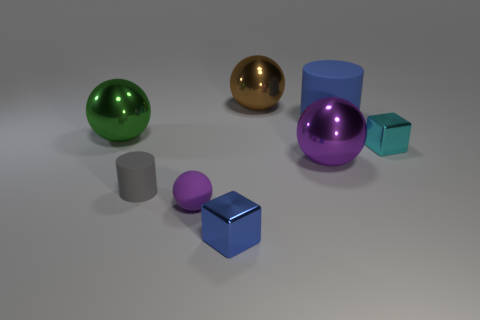Add 2 small purple shiny objects. How many objects exist? 10 Subtract all blocks. How many objects are left? 6 Add 7 small gray rubber cylinders. How many small gray rubber cylinders are left? 8 Add 8 tiny spheres. How many tiny spheres exist? 9 Subtract 1 gray cylinders. How many objects are left? 7 Subtract all large red rubber spheres. Subtract all tiny blue cubes. How many objects are left? 7 